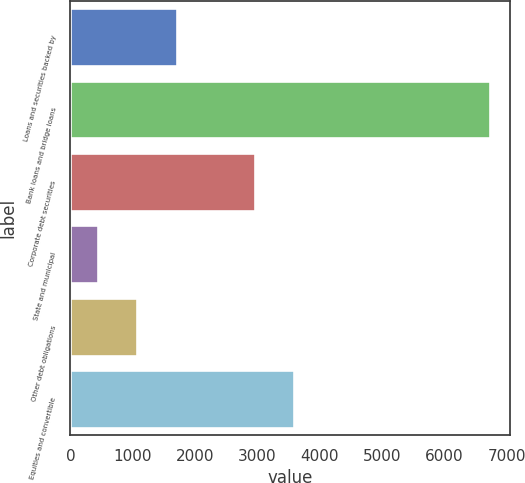<chart> <loc_0><loc_0><loc_500><loc_500><bar_chart><fcel>Loans and securities backed by<fcel>Bank loans and bridge loans<fcel>Corporate debt securities<fcel>State and municipal<fcel>Other debt obligations<fcel>Equities and convertible<nl><fcel>1703.4<fcel>6725<fcel>2958.8<fcel>448<fcel>1075.7<fcel>3586.5<nl></chart> 